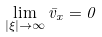Convert formula to latex. <formula><loc_0><loc_0><loc_500><loc_500>\lim _ { | \xi | \to \infty } \bar { v } _ { x } = 0</formula> 